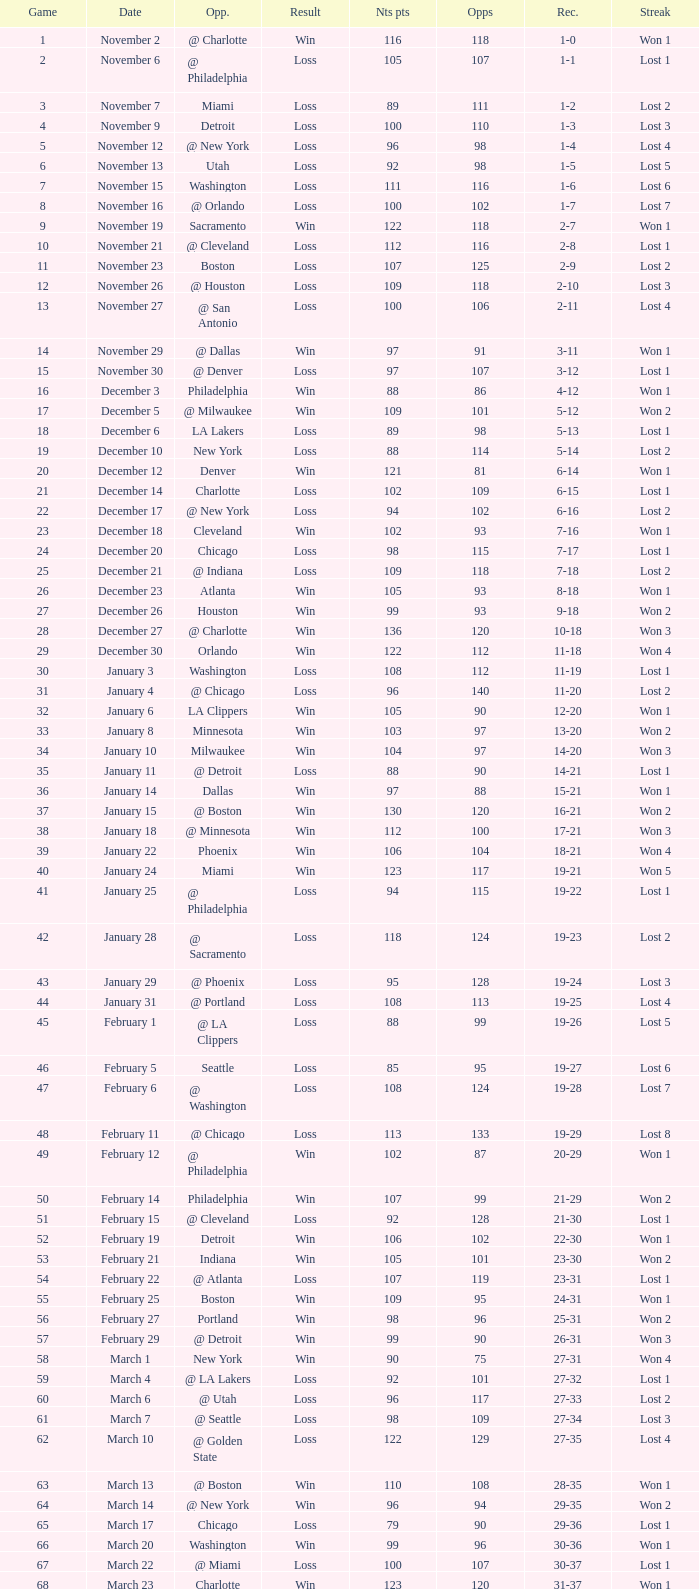How many opponents were there in a game higher than 20 on January 28? 124.0. 